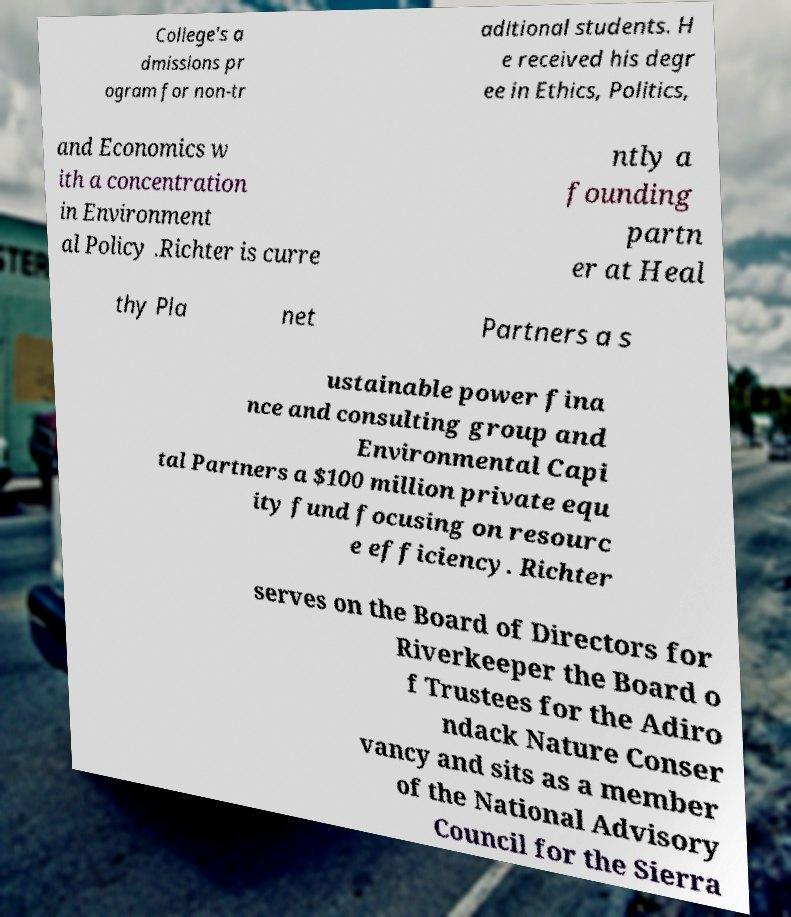Please read and relay the text visible in this image. What does it say? College's a dmissions pr ogram for non-tr aditional students. H e received his degr ee in Ethics, Politics, and Economics w ith a concentration in Environment al Policy .Richter is curre ntly a founding partn er at Heal thy Pla net Partners a s ustainable power fina nce and consulting group and Environmental Capi tal Partners a $100 million private equ ity fund focusing on resourc e efficiency. Richter serves on the Board of Directors for Riverkeeper the Board o f Trustees for the Adiro ndack Nature Conser vancy and sits as a member of the National Advisory Council for the Sierra 